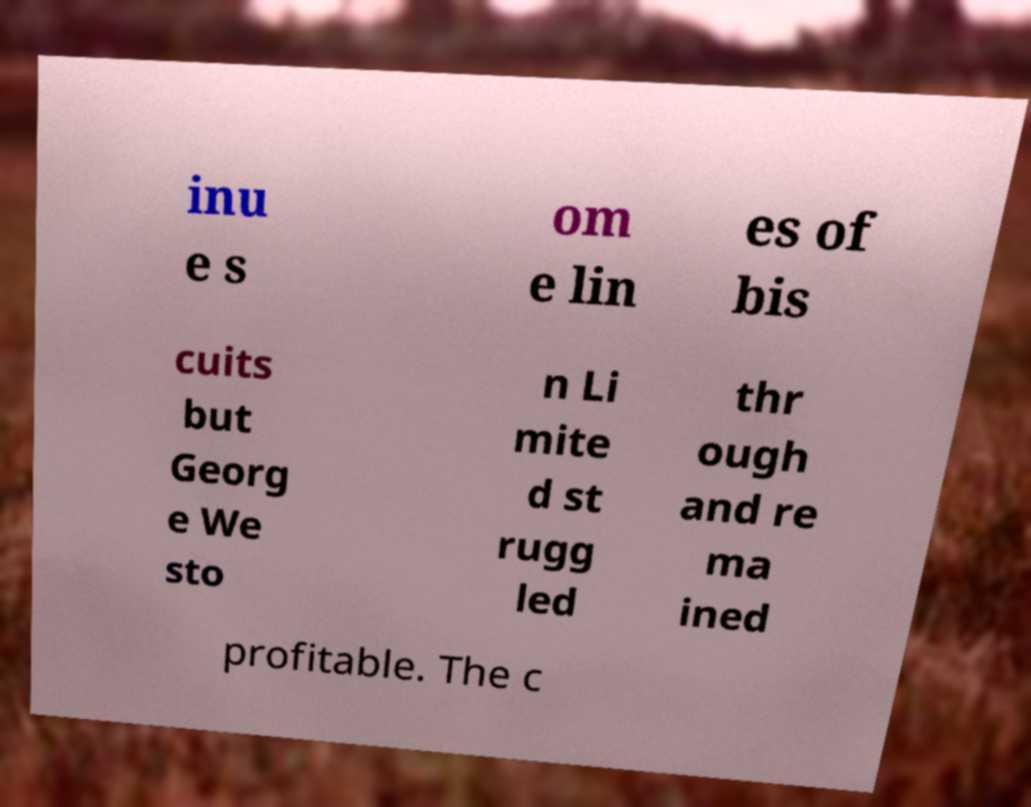What messages or text are displayed in this image? I need them in a readable, typed format. inu e s om e lin es of bis cuits but Georg e We sto n Li mite d st rugg led thr ough and re ma ined profitable. The c 